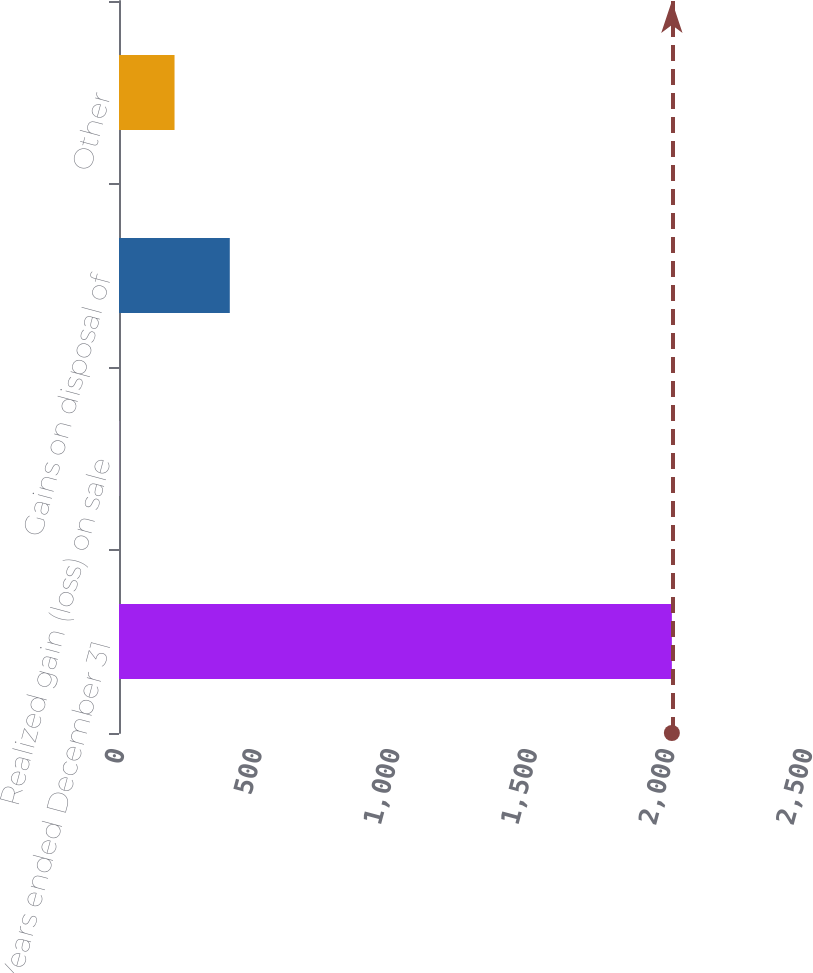Convert chart. <chart><loc_0><loc_0><loc_500><loc_500><bar_chart><fcel>Years ended December 31<fcel>Realized gain (loss) on sale<fcel>Gains on disposal of<fcel>Other<nl><fcel>2009<fcel>1<fcel>402.6<fcel>201.8<nl></chart> 